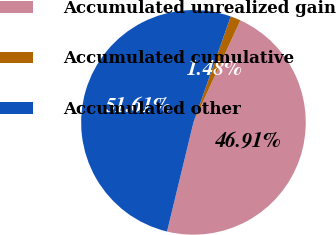<chart> <loc_0><loc_0><loc_500><loc_500><pie_chart><fcel>Accumulated unrealized gain<fcel>Accumulated cumulative<fcel>Accumulated other<nl><fcel>46.91%<fcel>1.48%<fcel>51.6%<nl></chart> 